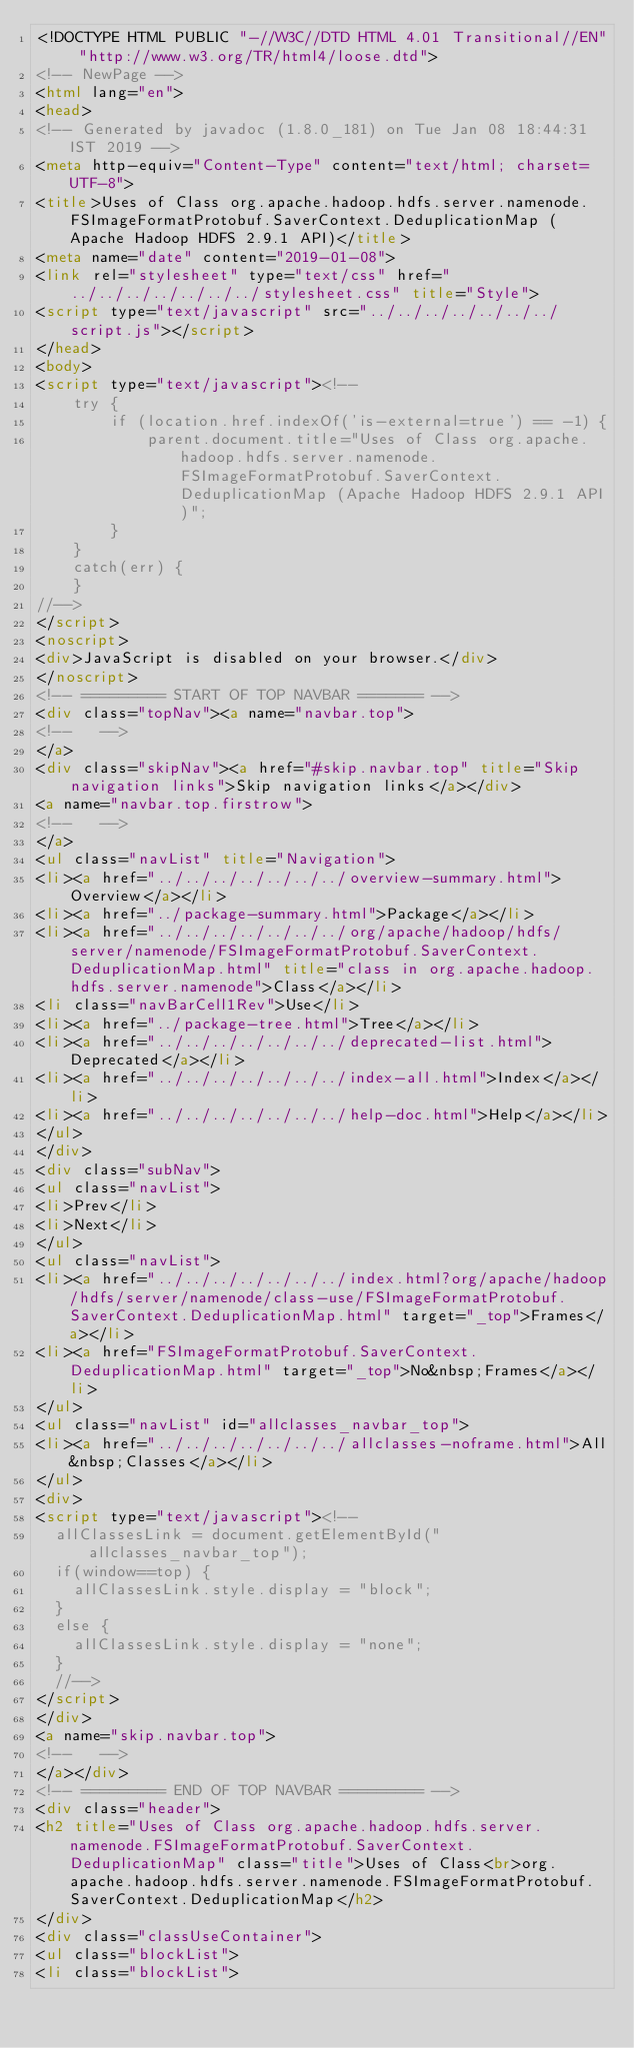<code> <loc_0><loc_0><loc_500><loc_500><_HTML_><!DOCTYPE HTML PUBLIC "-//W3C//DTD HTML 4.01 Transitional//EN" "http://www.w3.org/TR/html4/loose.dtd">
<!-- NewPage -->
<html lang="en">
<head>
<!-- Generated by javadoc (1.8.0_181) on Tue Jan 08 18:44:31 IST 2019 -->
<meta http-equiv="Content-Type" content="text/html; charset=UTF-8">
<title>Uses of Class org.apache.hadoop.hdfs.server.namenode.FSImageFormatProtobuf.SaverContext.DeduplicationMap (Apache Hadoop HDFS 2.9.1 API)</title>
<meta name="date" content="2019-01-08">
<link rel="stylesheet" type="text/css" href="../../../../../../../stylesheet.css" title="Style">
<script type="text/javascript" src="../../../../../../../script.js"></script>
</head>
<body>
<script type="text/javascript"><!--
    try {
        if (location.href.indexOf('is-external=true') == -1) {
            parent.document.title="Uses of Class org.apache.hadoop.hdfs.server.namenode.FSImageFormatProtobuf.SaverContext.DeduplicationMap (Apache Hadoop HDFS 2.9.1 API)";
        }
    }
    catch(err) {
    }
//-->
</script>
<noscript>
<div>JavaScript is disabled on your browser.</div>
</noscript>
<!-- ========= START OF TOP NAVBAR ======= -->
<div class="topNav"><a name="navbar.top">
<!--   -->
</a>
<div class="skipNav"><a href="#skip.navbar.top" title="Skip navigation links">Skip navigation links</a></div>
<a name="navbar.top.firstrow">
<!--   -->
</a>
<ul class="navList" title="Navigation">
<li><a href="../../../../../../../overview-summary.html">Overview</a></li>
<li><a href="../package-summary.html">Package</a></li>
<li><a href="../../../../../../../org/apache/hadoop/hdfs/server/namenode/FSImageFormatProtobuf.SaverContext.DeduplicationMap.html" title="class in org.apache.hadoop.hdfs.server.namenode">Class</a></li>
<li class="navBarCell1Rev">Use</li>
<li><a href="../package-tree.html">Tree</a></li>
<li><a href="../../../../../../../deprecated-list.html">Deprecated</a></li>
<li><a href="../../../../../../../index-all.html">Index</a></li>
<li><a href="../../../../../../../help-doc.html">Help</a></li>
</ul>
</div>
<div class="subNav">
<ul class="navList">
<li>Prev</li>
<li>Next</li>
</ul>
<ul class="navList">
<li><a href="../../../../../../../index.html?org/apache/hadoop/hdfs/server/namenode/class-use/FSImageFormatProtobuf.SaverContext.DeduplicationMap.html" target="_top">Frames</a></li>
<li><a href="FSImageFormatProtobuf.SaverContext.DeduplicationMap.html" target="_top">No&nbsp;Frames</a></li>
</ul>
<ul class="navList" id="allclasses_navbar_top">
<li><a href="../../../../../../../allclasses-noframe.html">All&nbsp;Classes</a></li>
</ul>
<div>
<script type="text/javascript"><!--
  allClassesLink = document.getElementById("allclasses_navbar_top");
  if(window==top) {
    allClassesLink.style.display = "block";
  }
  else {
    allClassesLink.style.display = "none";
  }
  //-->
</script>
</div>
<a name="skip.navbar.top">
<!--   -->
</a></div>
<!-- ========= END OF TOP NAVBAR ========= -->
<div class="header">
<h2 title="Uses of Class org.apache.hadoop.hdfs.server.namenode.FSImageFormatProtobuf.SaverContext.DeduplicationMap" class="title">Uses of Class<br>org.apache.hadoop.hdfs.server.namenode.FSImageFormatProtobuf.SaverContext.DeduplicationMap</h2>
</div>
<div class="classUseContainer">
<ul class="blockList">
<li class="blockList"></code> 